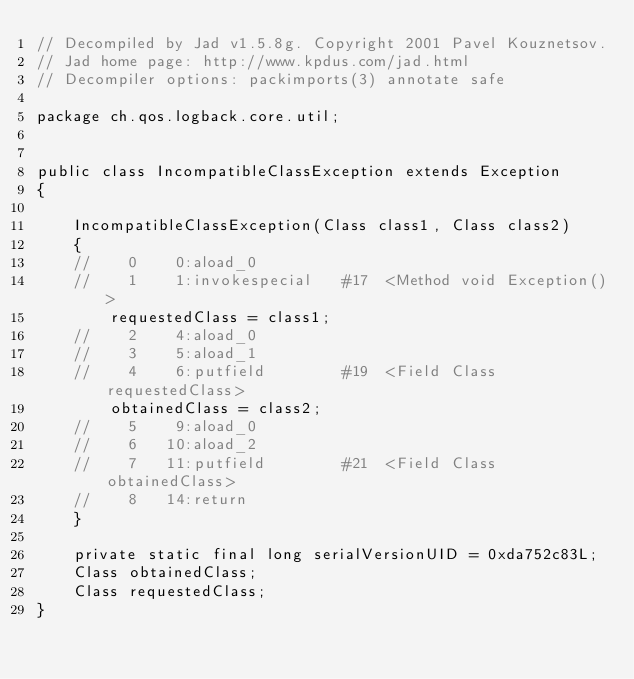Convert code to text. <code><loc_0><loc_0><loc_500><loc_500><_Java_>// Decompiled by Jad v1.5.8g. Copyright 2001 Pavel Kouznetsov.
// Jad home page: http://www.kpdus.com/jad.html
// Decompiler options: packimports(3) annotate safe 

package ch.qos.logback.core.util;


public class IncompatibleClassException extends Exception
{

	IncompatibleClassException(Class class1, Class class2)
	{
	//    0    0:aload_0         
	//    1    1:invokespecial   #17  <Method void Exception()>
		requestedClass = class1;
	//    2    4:aload_0         
	//    3    5:aload_1         
	//    4    6:putfield        #19  <Field Class requestedClass>
		obtainedClass = class2;
	//    5    9:aload_0         
	//    6   10:aload_2         
	//    7   11:putfield        #21  <Field Class obtainedClass>
	//    8   14:return          
	}

	private static final long serialVersionUID = 0xda752c83L;
	Class obtainedClass;
	Class requestedClass;
}
</code> 